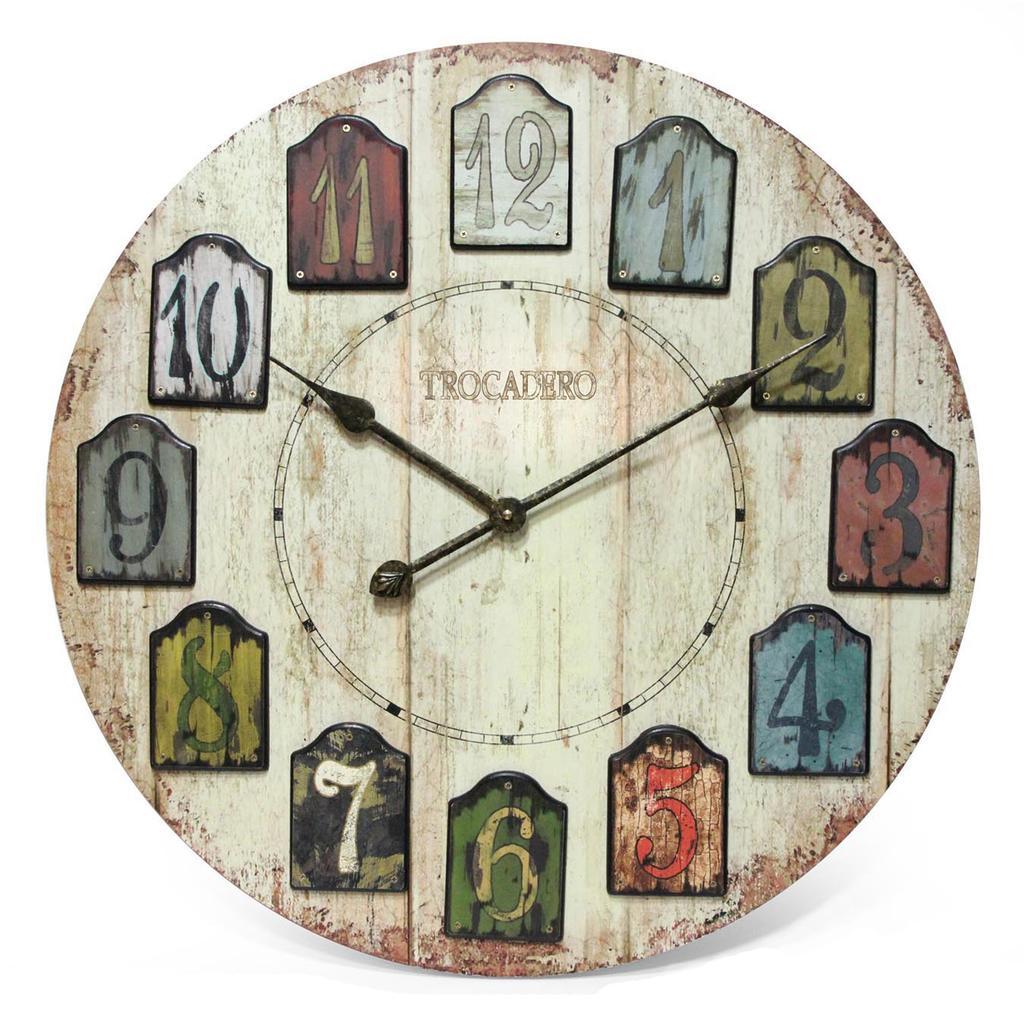<image>
Summarize the visual content of the image. a Trocadero analog clock with weather beaten numbers 